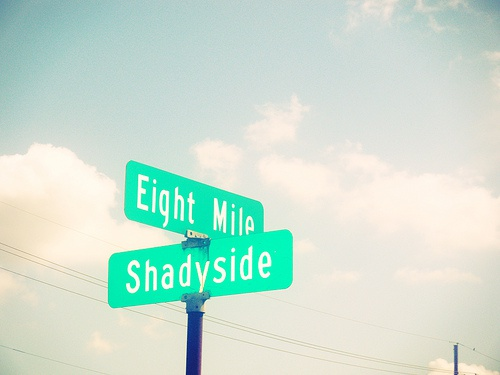Describe the objects in this image and their specific colors. I can see various objects in this image with different colors. 